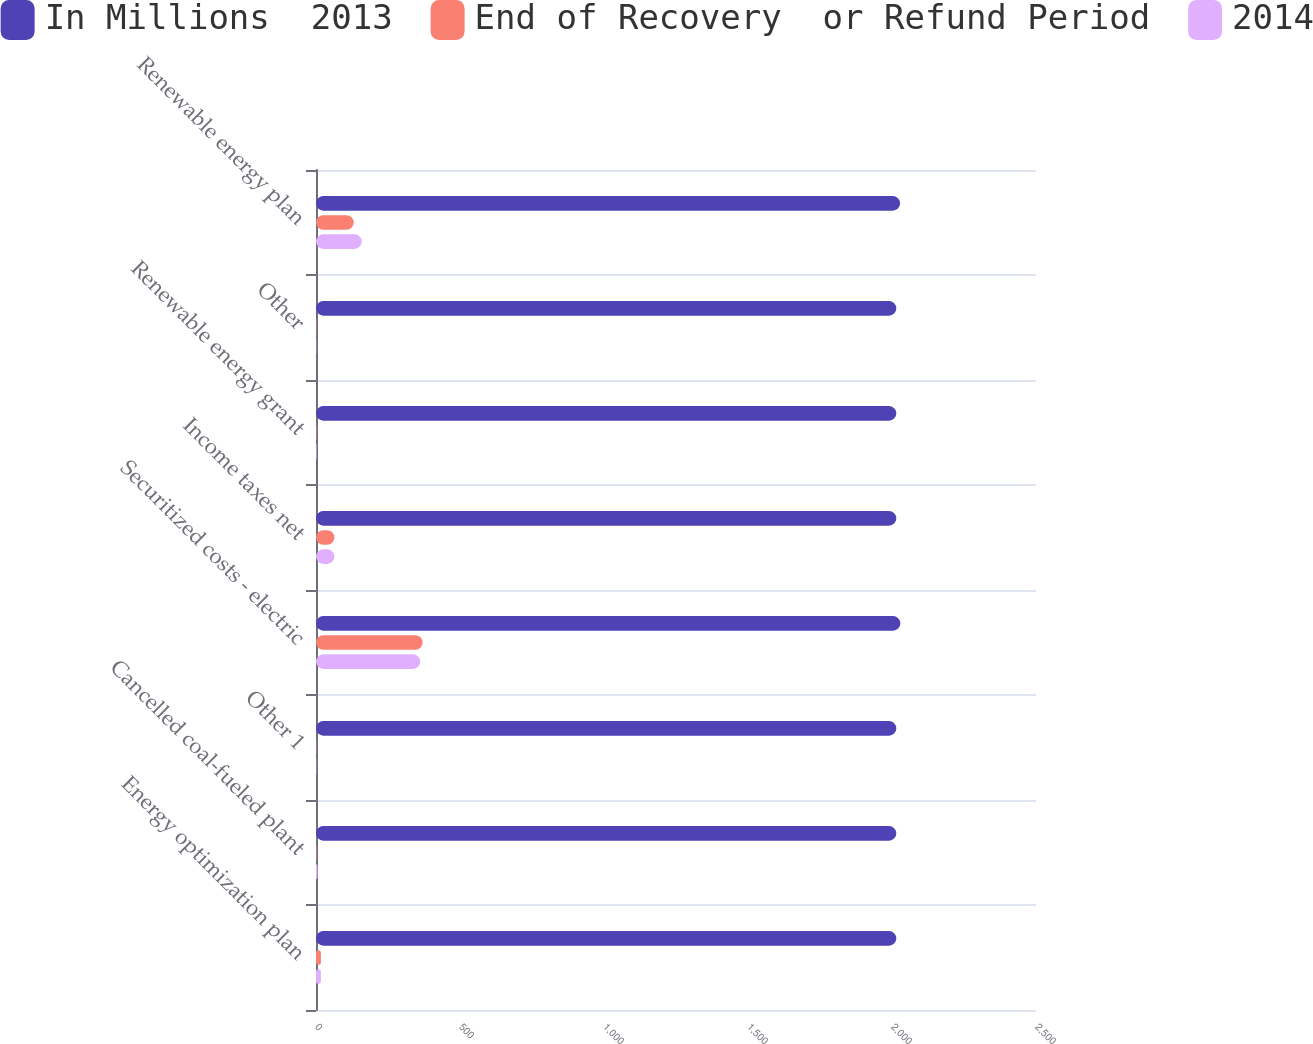Convert chart to OTSL. <chart><loc_0><loc_0><loc_500><loc_500><stacked_bar_chart><ecel><fcel>Energy optimization plan<fcel>Cancelled coal-fueled plant<fcel>Other 1<fcel>Securitized costs - electric<fcel>Income taxes net<fcel>Renewable energy grant<fcel>Other<fcel>Renewable energy plan<nl><fcel>In Millions  2013<fcel>2015<fcel>2015<fcel>2015<fcel>2029<fcel>2015<fcel>2015<fcel>2015<fcel>2028<nl><fcel>End of Recovery  or Refund Period<fcel>17<fcel>2<fcel>1<fcel>370<fcel>64<fcel>2<fcel>1<fcel>131<nl><fcel>2014<fcel>17<fcel>5<fcel>1<fcel>362<fcel>64<fcel>2<fcel>1<fcel>159<nl></chart> 